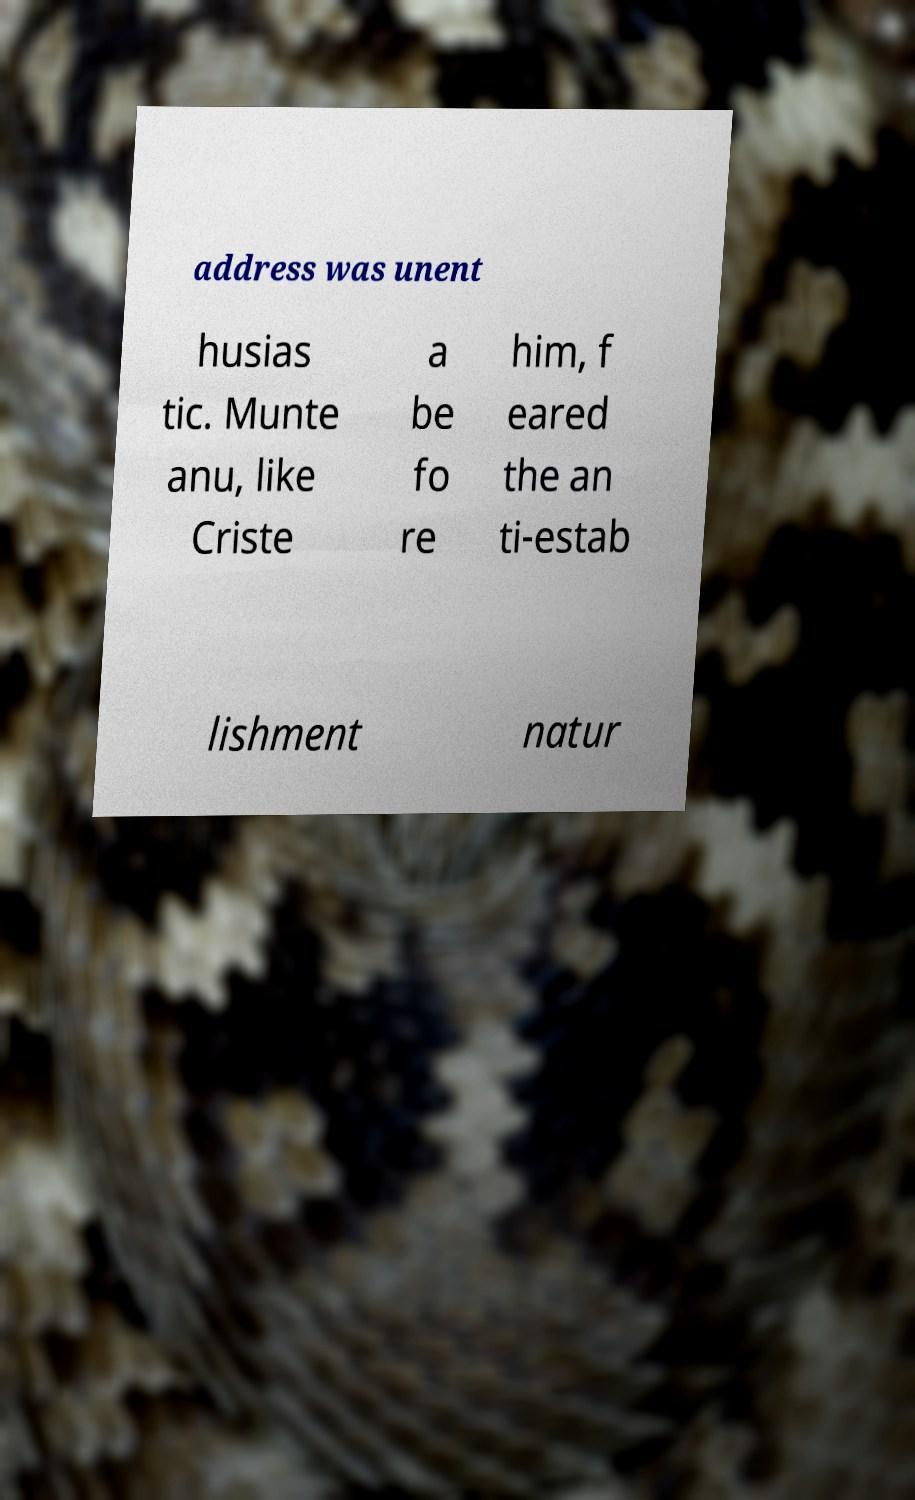Please read and relay the text visible in this image. What does it say? address was unent husias tic. Munte anu, like Criste a be fo re him, f eared the an ti-estab lishment natur 